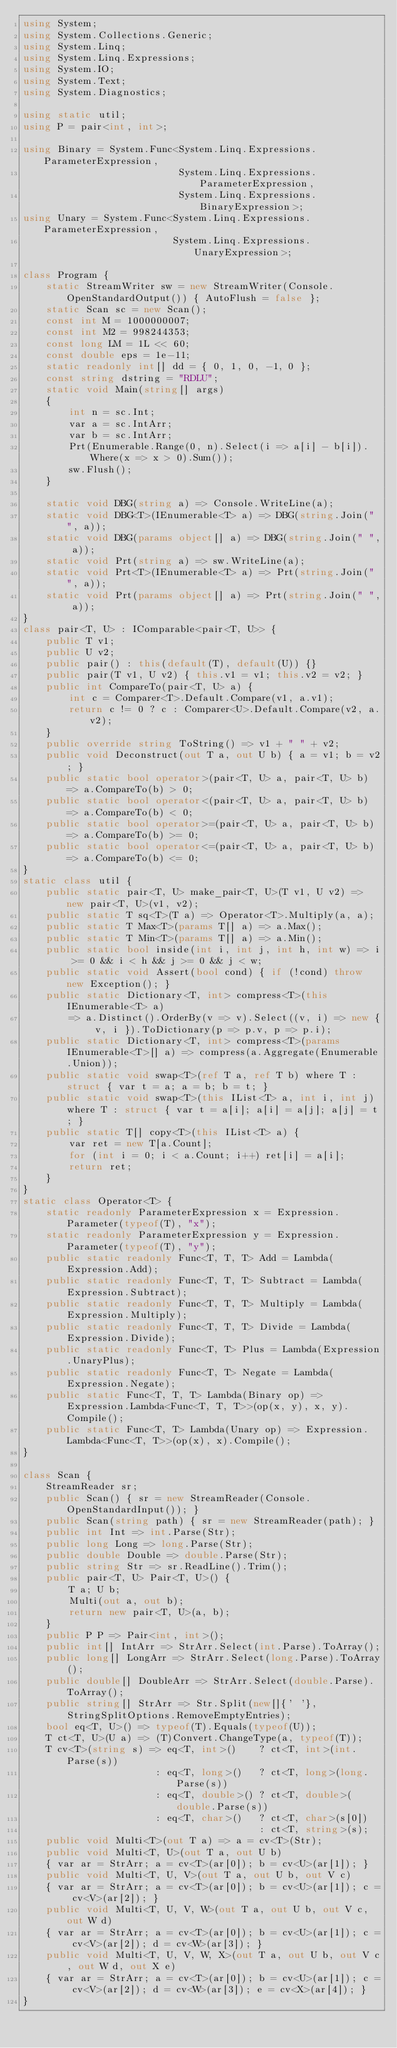<code> <loc_0><loc_0><loc_500><loc_500><_C#_>using System;
using System.Collections.Generic;
using System.Linq;
using System.Linq.Expressions;
using System.IO;
using System.Text;
using System.Diagnostics;

using static util;
using P = pair<int, int>;

using Binary = System.Func<System.Linq.Expressions.ParameterExpression,
                           System.Linq.Expressions.ParameterExpression,
                           System.Linq.Expressions.BinaryExpression>;
using Unary = System.Func<System.Linq.Expressions.ParameterExpression,
                          System.Linq.Expressions.UnaryExpression>;

class Program {
    static StreamWriter sw = new StreamWriter(Console.OpenStandardOutput()) { AutoFlush = false };
    static Scan sc = new Scan();
    const int M = 1000000007;
    const int M2 = 998244353;
    const long LM = 1L << 60;
    const double eps = 1e-11;
    static readonly int[] dd = { 0, 1, 0, -1, 0 };
    const string dstring = "RDLU";
    static void Main(string[] args)
    {
        int n = sc.Int;
        var a = sc.IntArr;
        var b = sc.IntArr;
        Prt(Enumerable.Range(0, n).Select(i => a[i] - b[i]).Where(x => x > 0).Sum());
        sw.Flush();
    }

    static void DBG(string a) => Console.WriteLine(a);
    static void DBG<T>(IEnumerable<T> a) => DBG(string.Join(" ", a));
    static void DBG(params object[] a) => DBG(string.Join(" ", a));
    static void Prt(string a) => sw.WriteLine(a);
    static void Prt<T>(IEnumerable<T> a) => Prt(string.Join(" ", a));
    static void Prt(params object[] a) => Prt(string.Join(" ", a));
}
class pair<T, U> : IComparable<pair<T, U>> {
    public T v1;
    public U v2;
    public pair() : this(default(T), default(U)) {}
    public pair(T v1, U v2) { this.v1 = v1; this.v2 = v2; }
    public int CompareTo(pair<T, U> a) {
        int c = Comparer<T>.Default.Compare(v1, a.v1);
        return c != 0 ? c : Comparer<U>.Default.Compare(v2, a.v2);
    }
    public override string ToString() => v1 + " " + v2;
    public void Deconstruct(out T a, out U b) { a = v1; b = v2; }
    public static bool operator>(pair<T, U> a, pair<T, U> b) => a.CompareTo(b) > 0;
    public static bool operator<(pair<T, U> a, pair<T, U> b) => a.CompareTo(b) < 0;
    public static bool operator>=(pair<T, U> a, pair<T, U> b) => a.CompareTo(b) >= 0;
    public static bool operator<=(pair<T, U> a, pair<T, U> b) => a.CompareTo(b) <= 0;
}
static class util {
    public static pair<T, U> make_pair<T, U>(T v1, U v2) => new pair<T, U>(v1, v2);
    public static T sq<T>(T a) => Operator<T>.Multiply(a, a);
    public static T Max<T>(params T[] a) => a.Max();
    public static T Min<T>(params T[] a) => a.Min();
    public static bool inside(int i, int j, int h, int w) => i >= 0 && i < h && j >= 0 && j < w;
    public static void Assert(bool cond) { if (!cond) throw new Exception(); }
    public static Dictionary<T, int> compress<T>(this IEnumerable<T> a)
        => a.Distinct().OrderBy(v => v).Select((v, i) => new { v, i }).ToDictionary(p => p.v, p => p.i);
    public static Dictionary<T, int> compress<T>(params IEnumerable<T>[] a) => compress(a.Aggregate(Enumerable.Union));
    public static void swap<T>(ref T a, ref T b) where T : struct { var t = a; a = b; b = t; }
    public static void swap<T>(this IList<T> a, int i, int j) where T : struct { var t = a[i]; a[i] = a[j]; a[j] = t; }
    public static T[] copy<T>(this IList<T> a) {
        var ret = new T[a.Count];
        for (int i = 0; i < a.Count; i++) ret[i] = a[i];
        return ret;
    }
}
static class Operator<T> {
    static readonly ParameterExpression x = Expression.Parameter(typeof(T), "x");
    static readonly ParameterExpression y = Expression.Parameter(typeof(T), "y");
    public static readonly Func<T, T, T> Add = Lambda(Expression.Add);
    public static readonly Func<T, T, T> Subtract = Lambda(Expression.Subtract);
    public static readonly Func<T, T, T> Multiply = Lambda(Expression.Multiply);
    public static readonly Func<T, T, T> Divide = Lambda(Expression.Divide);
    public static readonly Func<T, T> Plus = Lambda(Expression.UnaryPlus);
    public static readonly Func<T, T> Negate = Lambda(Expression.Negate);
    public static Func<T, T, T> Lambda(Binary op) => Expression.Lambda<Func<T, T, T>>(op(x, y), x, y).Compile();
    public static Func<T, T> Lambda(Unary op) => Expression.Lambda<Func<T, T>>(op(x), x).Compile();
}

class Scan {
    StreamReader sr;
    public Scan() { sr = new StreamReader(Console.OpenStandardInput()); }
    public Scan(string path) { sr = new StreamReader(path); }
    public int Int => int.Parse(Str);
    public long Long => long.Parse(Str);
    public double Double => double.Parse(Str);
    public string Str => sr.ReadLine().Trim();
    public pair<T, U> Pair<T, U>() {
        T a; U b;
        Multi(out a, out b);
        return new pair<T, U>(a, b);
    }
    public P P => Pair<int, int>();
    public int[] IntArr => StrArr.Select(int.Parse).ToArray();
    public long[] LongArr => StrArr.Select(long.Parse).ToArray();
    public double[] DoubleArr => StrArr.Select(double.Parse).ToArray();
    public string[] StrArr => Str.Split(new[]{' '}, StringSplitOptions.RemoveEmptyEntries);
    bool eq<T, U>() => typeof(T).Equals(typeof(U));
    T ct<T, U>(U a) => (T)Convert.ChangeType(a, typeof(T));
    T cv<T>(string s) => eq<T, int>()    ? ct<T, int>(int.Parse(s))
                       : eq<T, long>()   ? ct<T, long>(long.Parse(s))
                       : eq<T, double>() ? ct<T, double>(double.Parse(s))
                       : eq<T, char>()   ? ct<T, char>(s[0])
                                         : ct<T, string>(s);
    public void Multi<T>(out T a) => a = cv<T>(Str);
    public void Multi<T, U>(out T a, out U b)
    { var ar = StrArr; a = cv<T>(ar[0]); b = cv<U>(ar[1]); }
    public void Multi<T, U, V>(out T a, out U b, out V c)
    { var ar = StrArr; a = cv<T>(ar[0]); b = cv<U>(ar[1]); c = cv<V>(ar[2]); }
    public void Multi<T, U, V, W>(out T a, out U b, out V c, out W d)
    { var ar = StrArr; a = cv<T>(ar[0]); b = cv<U>(ar[1]); c = cv<V>(ar[2]); d = cv<W>(ar[3]); }
    public void Multi<T, U, V, W, X>(out T a, out U b, out V c, out W d, out X e)
    { var ar = StrArr; a = cv<T>(ar[0]); b = cv<U>(ar[1]); c = cv<V>(ar[2]); d = cv<W>(ar[3]); e = cv<X>(ar[4]); }
}
</code> 